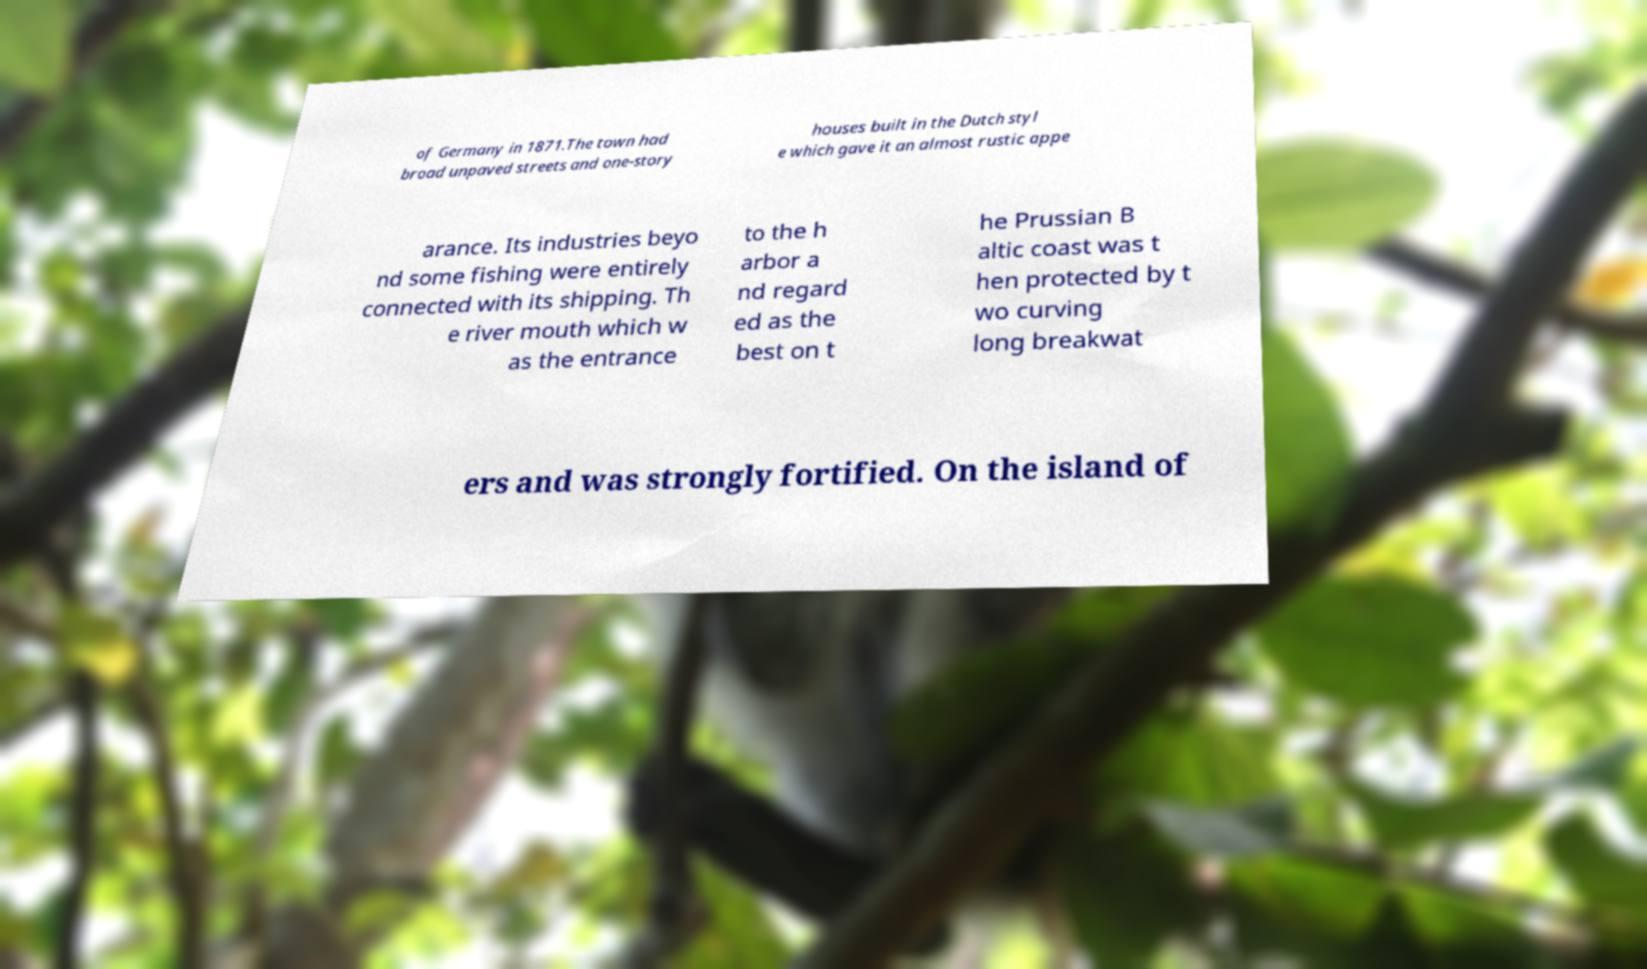There's text embedded in this image that I need extracted. Can you transcribe it verbatim? of Germany in 1871.The town had broad unpaved streets and one-story houses built in the Dutch styl e which gave it an almost rustic appe arance. Its industries beyo nd some fishing were entirely connected with its shipping. Th e river mouth which w as the entrance to the h arbor a nd regard ed as the best on t he Prussian B altic coast was t hen protected by t wo curving long breakwat ers and was strongly fortified. On the island of 